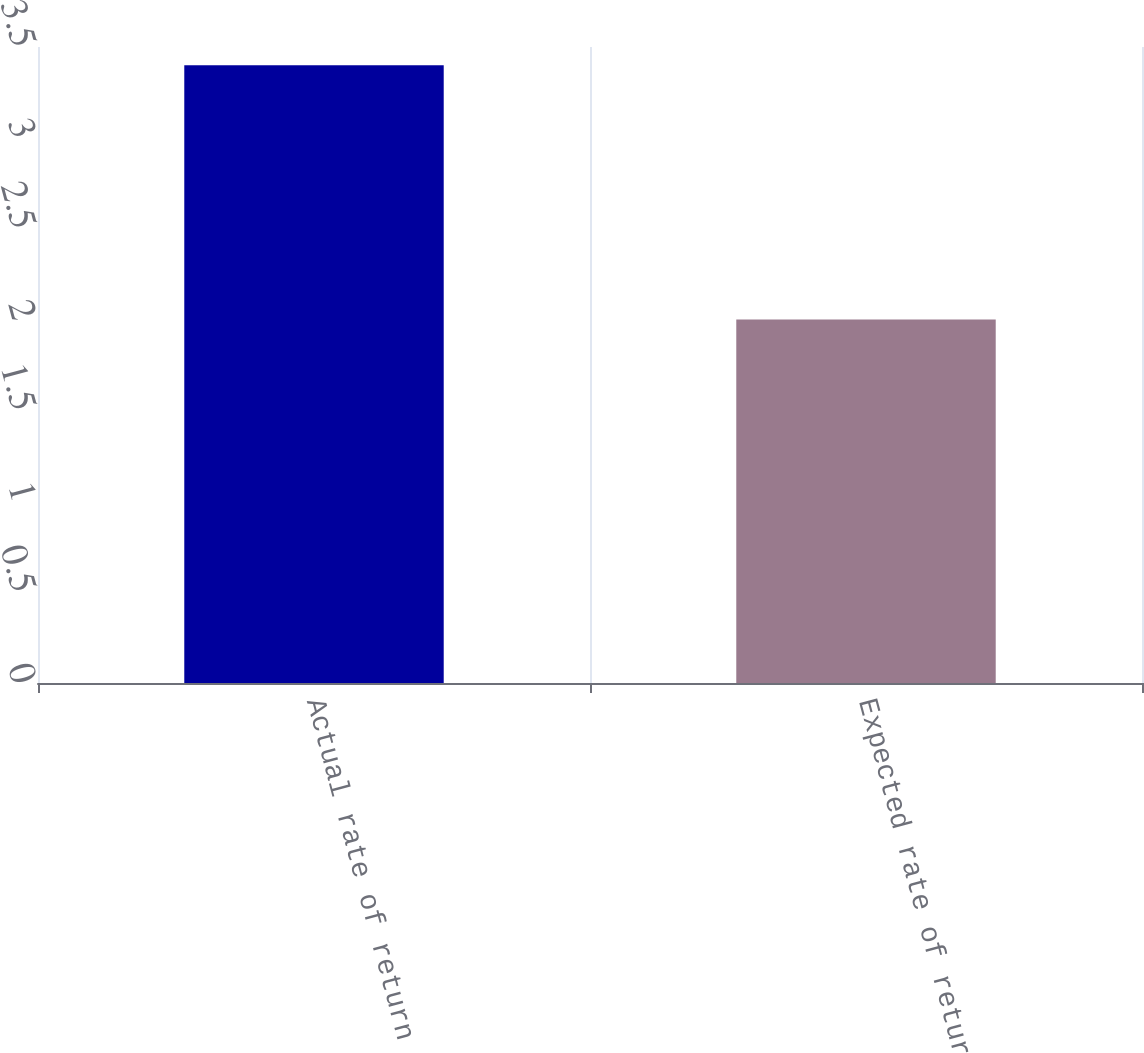Convert chart to OTSL. <chart><loc_0><loc_0><loc_500><loc_500><bar_chart><fcel>Actual rate of return<fcel>Expected rate of return<nl><fcel>3.4<fcel>2<nl></chart> 